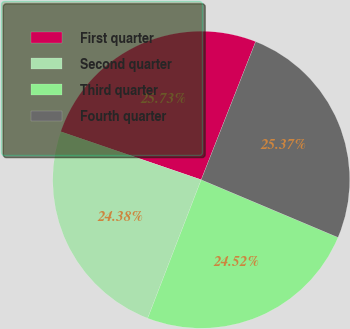Convert chart. <chart><loc_0><loc_0><loc_500><loc_500><pie_chart><fcel>First quarter<fcel>Second quarter<fcel>Third quarter<fcel>Fourth quarter<nl><fcel>25.73%<fcel>24.38%<fcel>24.52%<fcel>25.37%<nl></chart> 